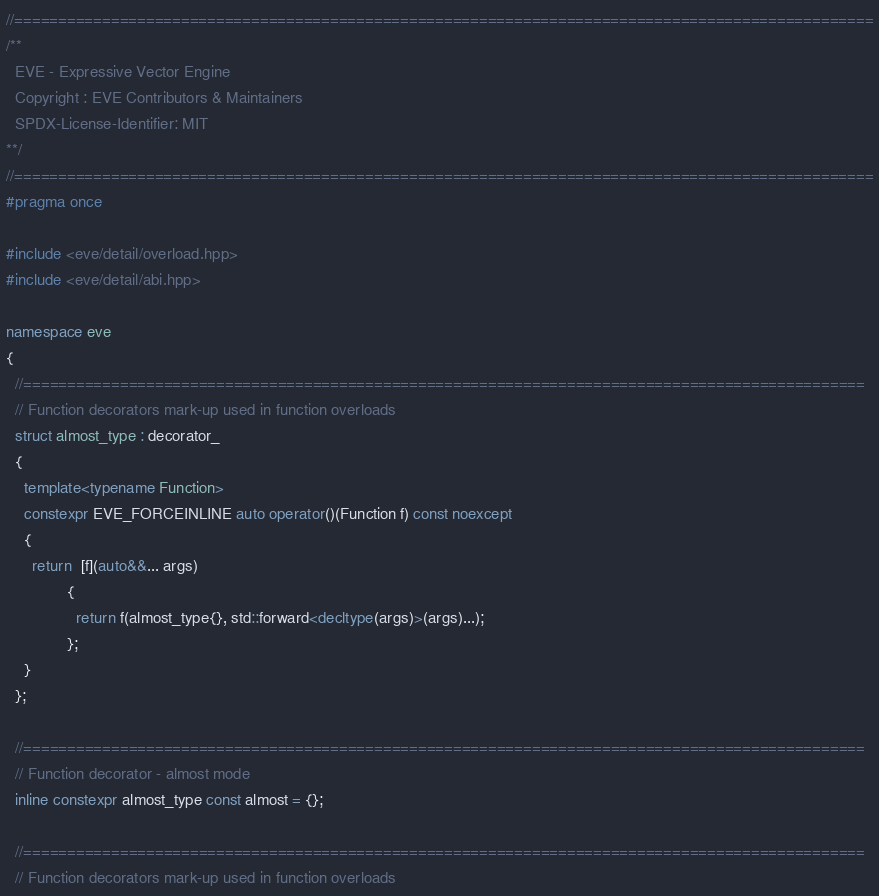Convert code to text. <code><loc_0><loc_0><loc_500><loc_500><_C++_>//==================================================================================================
/**
  EVE - Expressive Vector Engine
  Copyright : EVE Contributors & Maintainers
  SPDX-License-Identifier: MIT
**/
//==================================================================================================
#pragma once

#include <eve/detail/overload.hpp>
#include <eve/detail/abi.hpp>

namespace eve
{
  //================================================================================================
  // Function decorators mark-up used in function overloads
  struct almost_type : decorator_
  {
    template<typename Function>
    constexpr EVE_FORCEINLINE auto operator()(Function f) const noexcept
    {
      return  [f](auto&&... args)
              {
                return f(almost_type{}, std::forward<decltype(args)>(args)...);
              };
    }
  };

  //================================================================================================
  // Function decorator - almost mode
  inline constexpr almost_type const almost = {};

  //================================================================================================
  // Function decorators mark-up used in function overloads</code> 